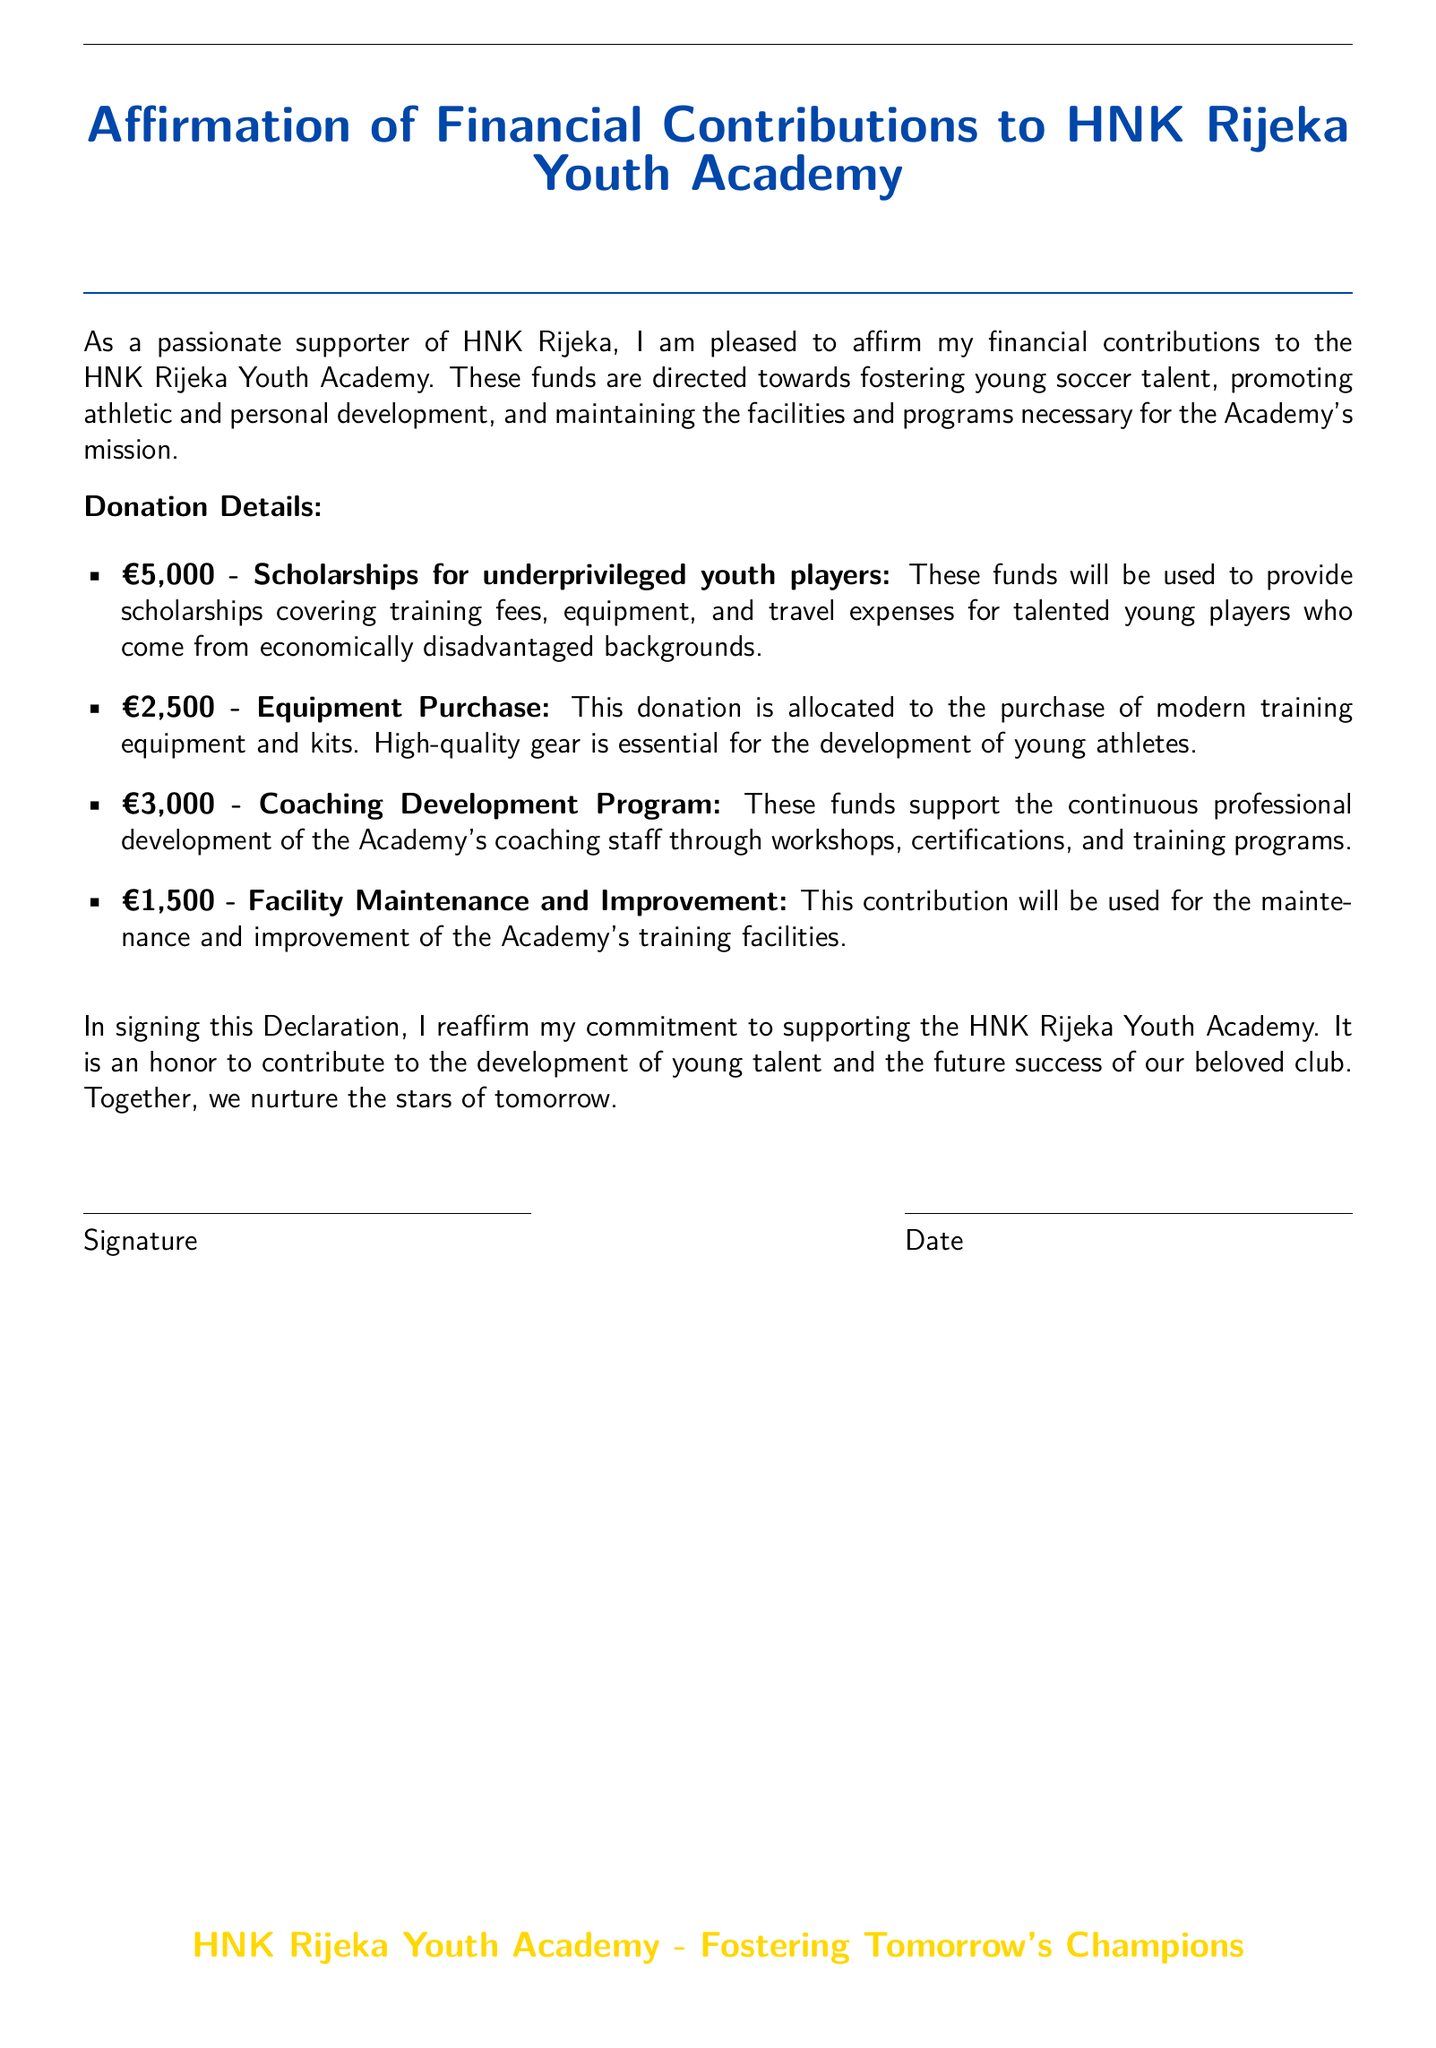What is the total amount of donations pledged? The total amount of donations can be calculated by adding all specified donation amounts: €5,000 + €2,500 + €3,000 + €1,500 = €12,000.
Answer: €12,000 What is the first item listed in the donation details? The first item in the donation details is the contribution for scholarships for underprivileged youth players.
Answer: Scholarships for underprivileged youth players How much is allocated for facility maintenance and improvement? The facility maintenance and improvement allocation is specifically cited in the document as €1,500.
Answer: €1,500 What is the purpose of the €2,500 donation? The purpose of the €2,500 donation is to purchase modern training equipment and kits, as stated in the document.
Answer: Equipment Purchase What is indicated as essential for the development of young athletes? The document states that high-quality gear is essential for the development of young athletes.
Answer: High-quality gear How many areas of funding are mentioned in the document? The document lists four specific areas of funding for donations.
Answer: Four What does the donor reaffirm by signing this Declaration? By signing this Declaration, the donor reaffirms their commitment to supporting the HNK Rijeka Youth Academy.
Answer: Commitment to supporting the Academy When is the last line of the document signed? The last section of the document is meant for the signature and the date, indicating the finalization of the Declaration.
Answer: Signature and Date 